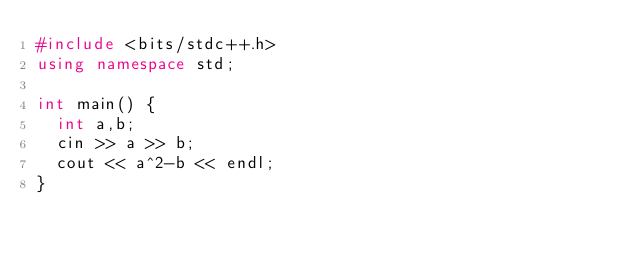Convert code to text. <code><loc_0><loc_0><loc_500><loc_500><_C++_>#include <bits/stdc++.h>
using namespace std;

int main() {
  int a,b;
  cin >> a >> b;
  cout << a^2-b << endl;
}</code> 